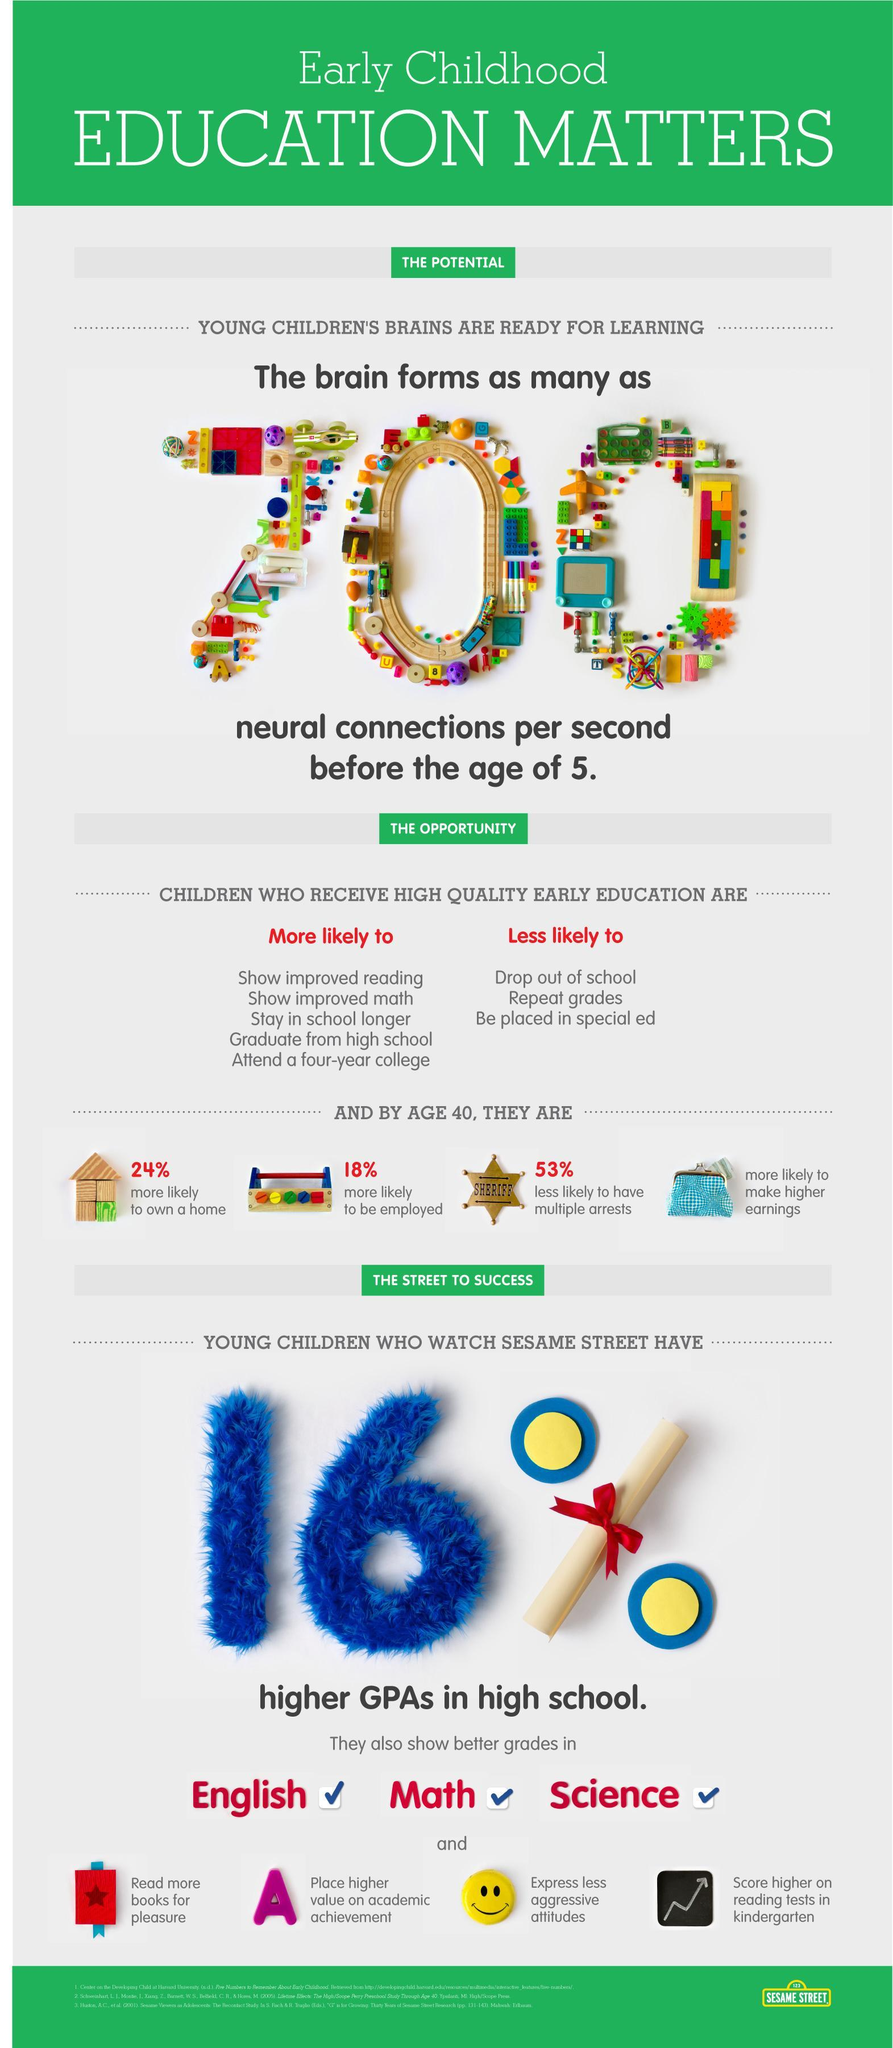How many subjects are in this infographic?
Answer the question with a short phrase. 3 